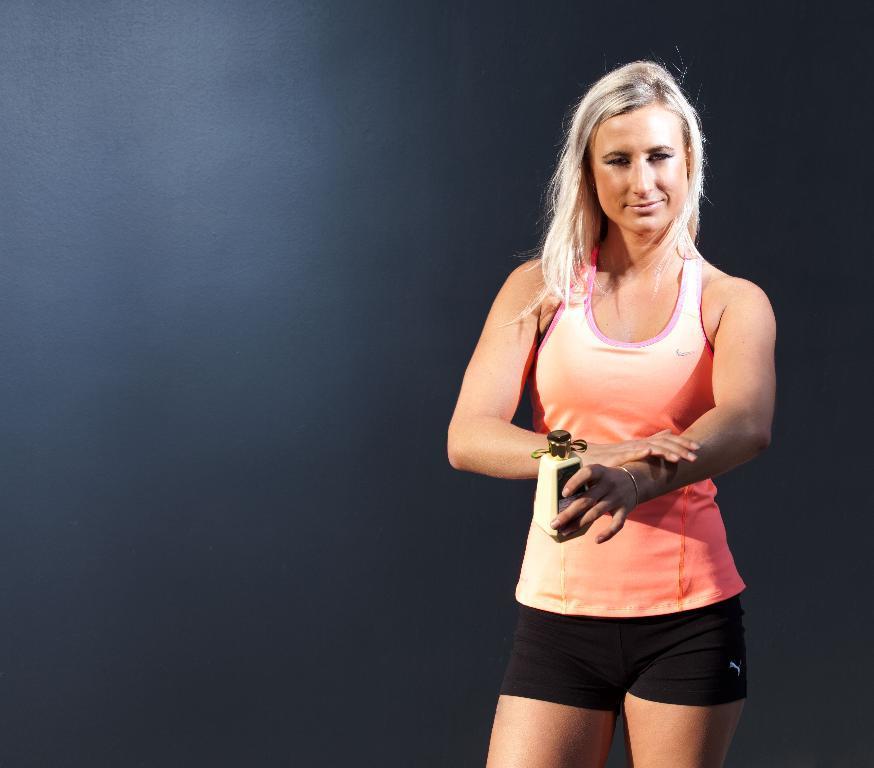How would you summarize this image in a sentence or two? In this image I can see woman standing and wearing peach and black color. She is holding something. I can see black color background. 